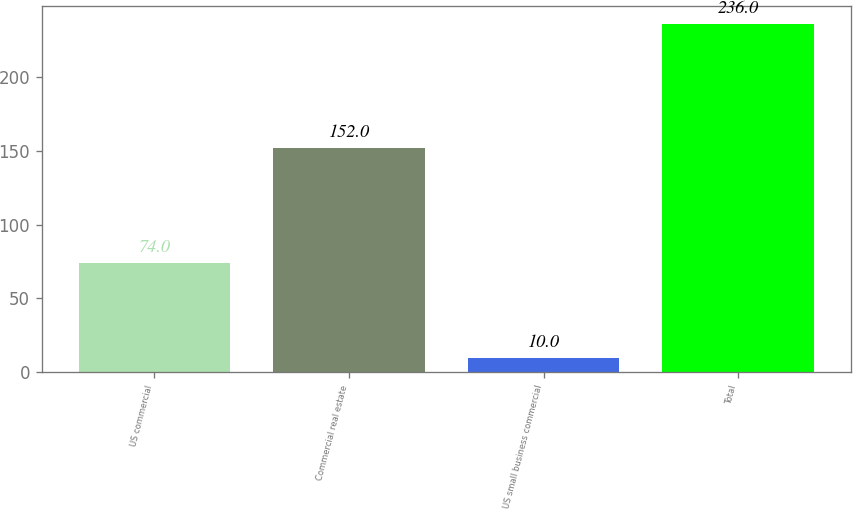<chart> <loc_0><loc_0><loc_500><loc_500><bar_chart><fcel>US commercial<fcel>Commercial real estate<fcel>US small business commercial<fcel>Total<nl><fcel>74<fcel>152<fcel>10<fcel>236<nl></chart> 